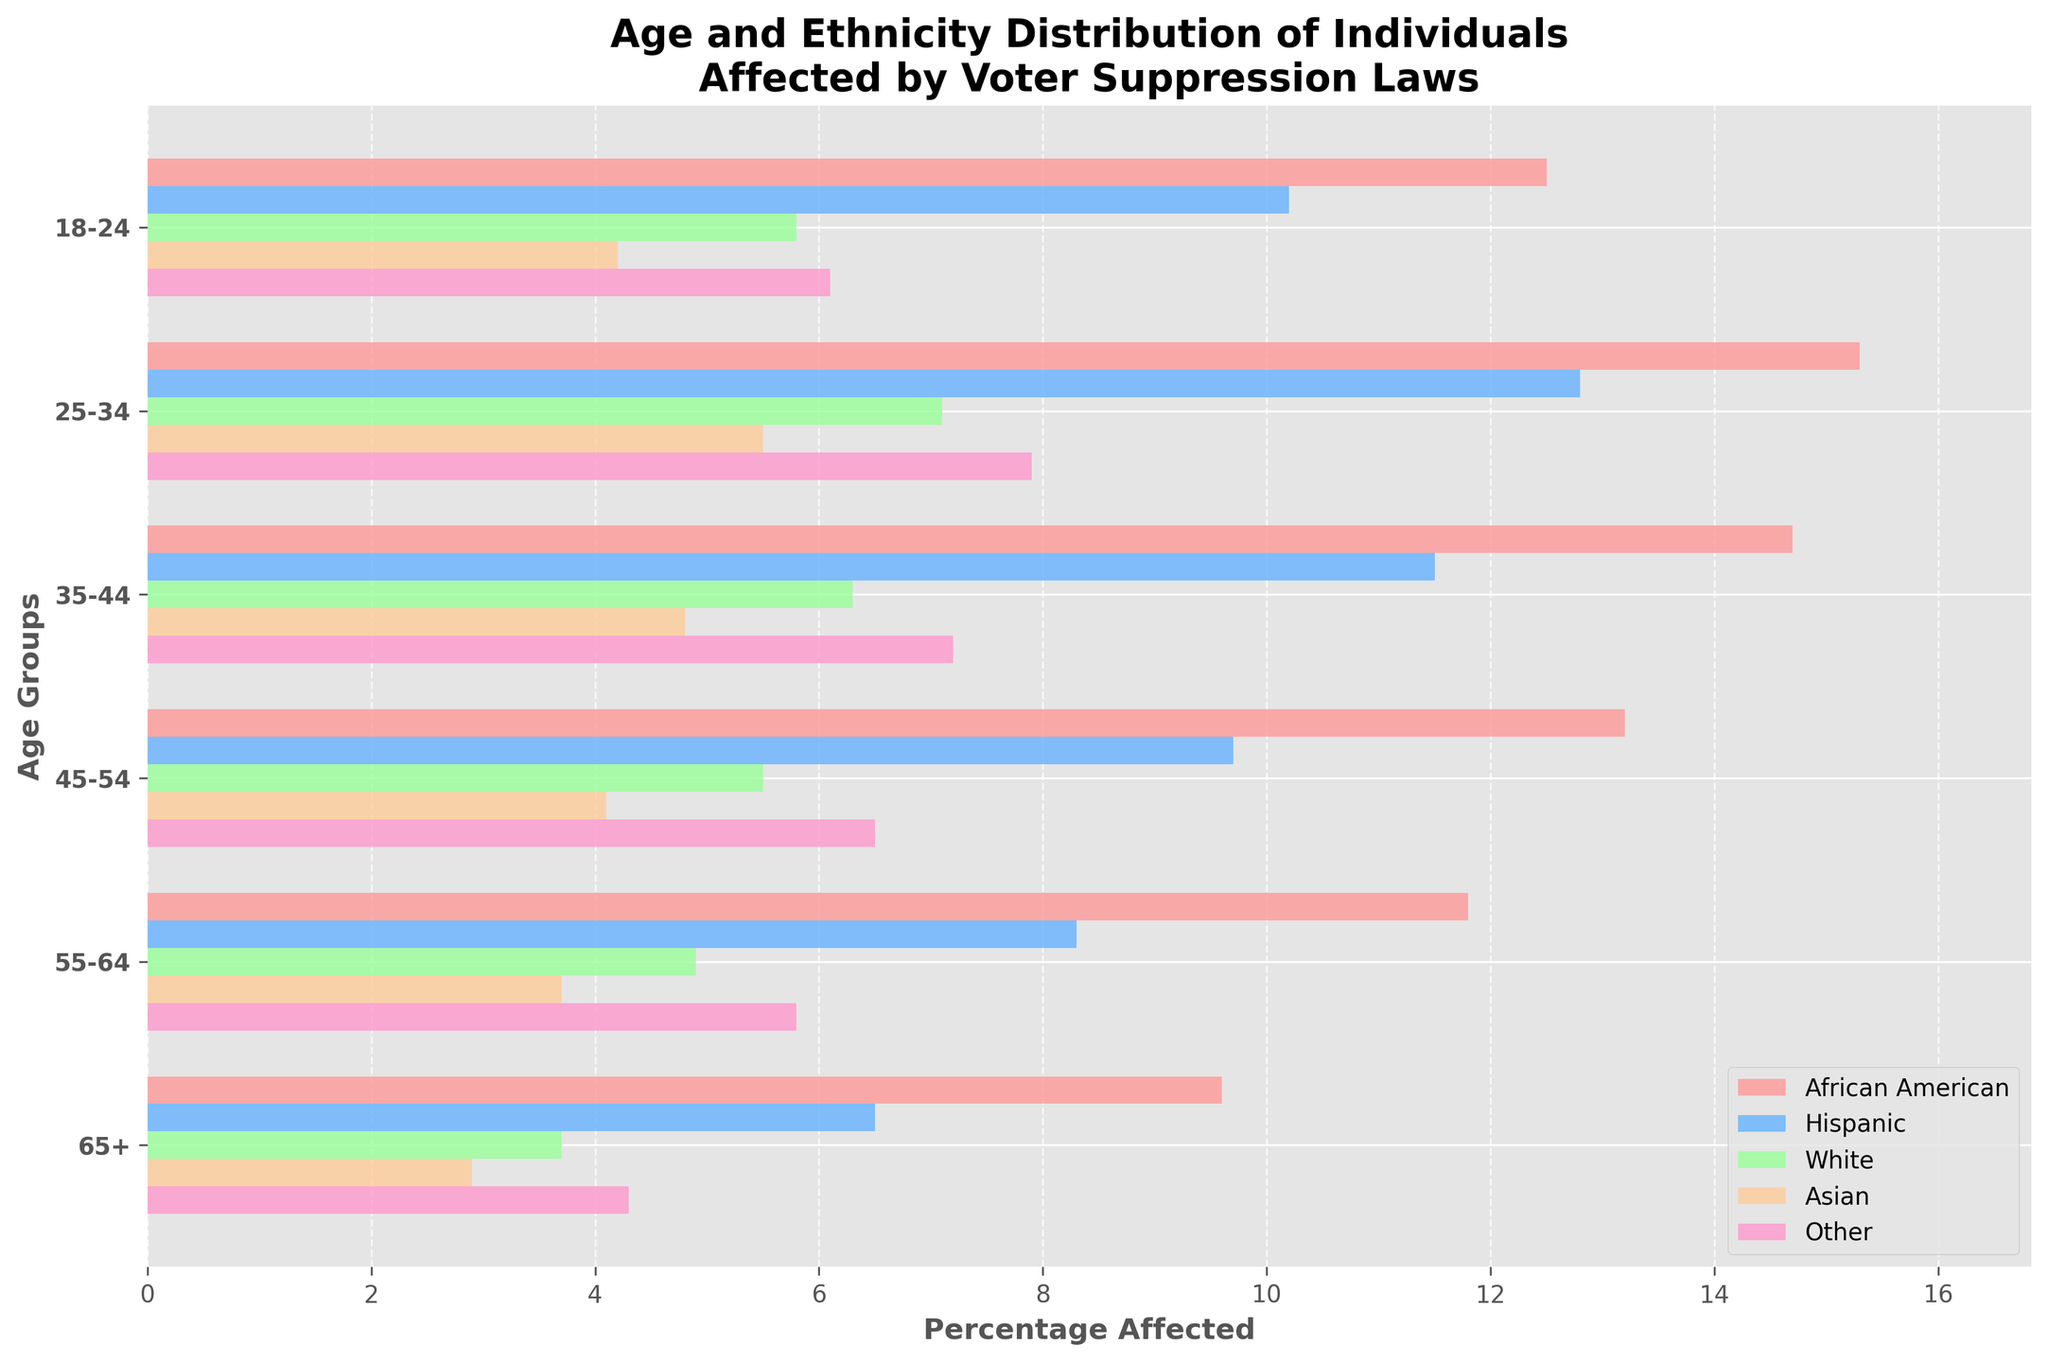What is the title of the figure? The title of the figure is typically located at the top and represents the overall subject of the visualized data. In this case, the title tells us that the figure presents the demographic distribution of individuals affected by voter suppression laws.
Answer: Age and Ethnicity Distribution of Individuals Affected by Voter Suppression Laws Which age group has the highest percentage of African American individuals affected by voter suppression laws? To determine this, observe the bars corresponding to African American individuals and identify which age group has the longest bar.
Answer: 25-34 Compare the percentages of Hispanic and Asian individuals in the 35-44 age group. Which is higher and by how much? Find the bars for Hispanic and Asian individuals in the 35-44 age group, note their lengths, and subtract the smaller percentage from the larger one. 11.5 - 4.8 = 6.7.
Answer: Hispanic by 6.7% What is the average percentage of White individuals affected across all age groups? To find this, sum the percentage values for White individuals across all age groups and then divide by the number of age groups: (5.8 + 7.1 + 6.3 + 5.5 + 4.9 + 3.7) / 6 = (33.3) / 6 = 5.55.
Answer: 5.55% Which ethnicity has the smallest percentage in the 18-24 age group? Look at the bars representing different ethnicities in the 18-24 age group and identify the shortest bar.
Answer: White How does the percentage of affected African American individuals in the 65+ age group compare to Hispanic individuals in the same age group? Compare the lengths of the bars for African American (9.6%) and Hispanic individuals (6.5%) in the 65+ age group.
Answer: African American is higher What is the total percentage of individuals aged 55-64 affected by voter suppression laws across all ethnicities? Sum the percentage values for all ethnicities in the 55-64 age group: 11.8 + 8.3 + 4.9 + 3.7 + 5.8 = 34.5%.
Answer: 34.5% Which age group shows the greatest diversity in terms of the percentages of affected individuals across different ethnicities? Diversity can be interpreted by looking for the age group with the most spread out (variable) percentage values across ethnicities. Here, the 25-34 age group shows high variability with percentages as 15.3, 12.8, 7.1, 5.5, and 7.9.
Answer: 25-34 In the 45-54 age group, what is the difference in percentage between the African American and Hispanic individuals? Identify the percentages for African American (13.2%) and Hispanic (9.7%) individuals in the 45-54 age group and subtract one from the other: 13.2 - 9.7 = 3.5.
Answer: 3.5% Overall, which ethnic group has the highest percentage affected by voter suppression laws across all age groups? Compare the highest percentages for each ethnic group across all age groups and identify the highest one among them. African American individuals show consistently high percentages like 15.3%, 14.7%, 13.2%, and 11.8%.
Answer: African American 